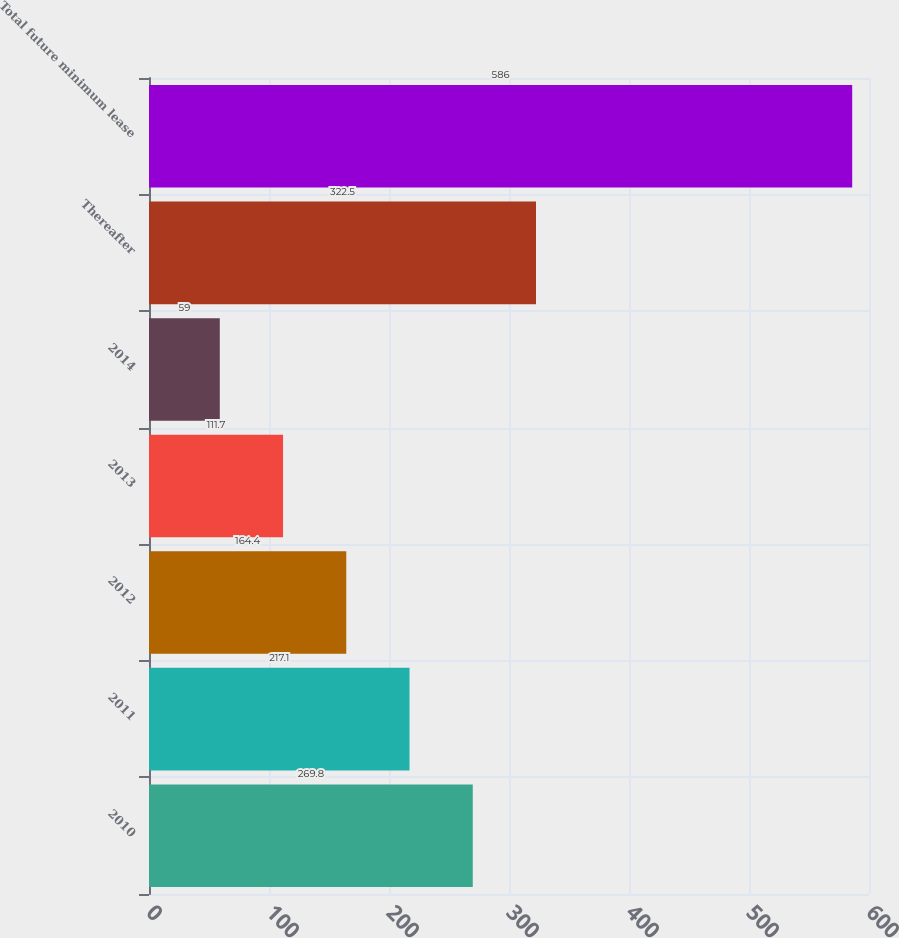Convert chart. <chart><loc_0><loc_0><loc_500><loc_500><bar_chart><fcel>2010<fcel>2011<fcel>2012<fcel>2013<fcel>2014<fcel>Thereafter<fcel>Total future minimum lease<nl><fcel>269.8<fcel>217.1<fcel>164.4<fcel>111.7<fcel>59<fcel>322.5<fcel>586<nl></chart> 